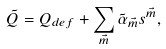<formula> <loc_0><loc_0><loc_500><loc_500>\tilde { Q } = Q _ { d e f } + \sum _ { \vec { m } } \tilde { \alpha } _ { \vec { m } } s ^ { \vec { m } } ,</formula> 